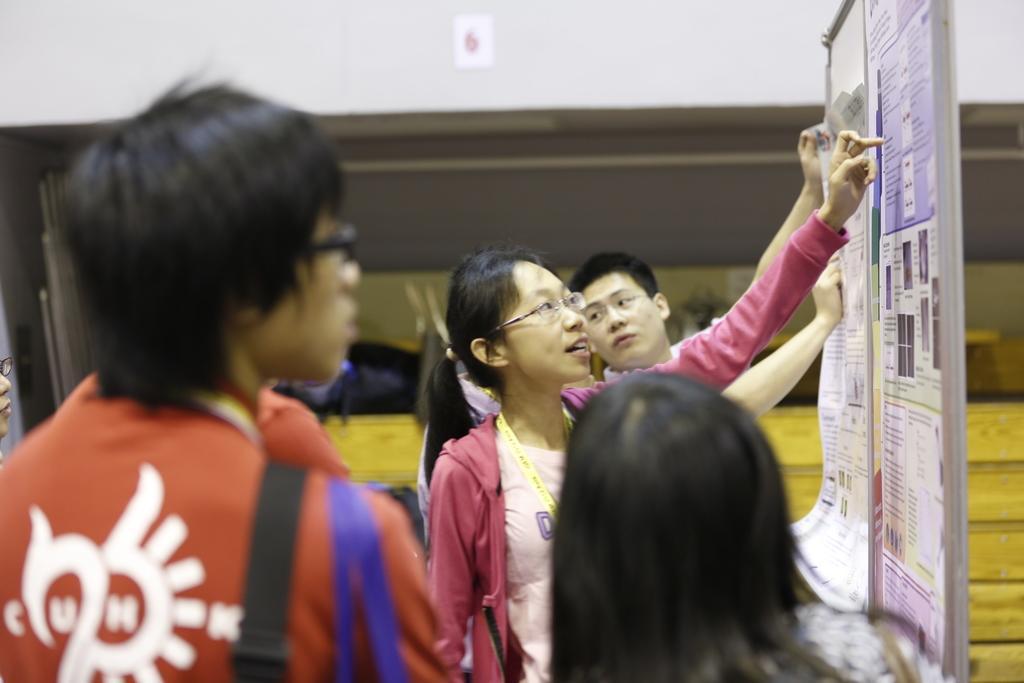In one or two sentences, can you explain what this image depicts? In this image I can see on the left side a person is looking at that side. This person wore dark red color t-shirt, in the middle a woman is pointing her finger to the board. She wore spectacles, t-shirt, Id card. Behind her other man is also there. On the right side it looks like a notice board with papers. 